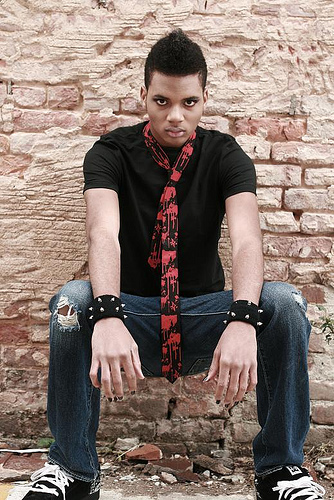Can you describe the setting and how it might relate to the person's mood? The setting appears to be an outdoor scene with a rustic brick wall as the backdrop. The wall's aged and weathered texture, along with the person's serious expression and seated pose, may suggest a contemplative or introspective mood, as if he's ruminating on life or seeking a moment of solitude. Does the environment tell us anything about the time of day or season? While specific details about the time of day or season aren't directly visible, the ambient lighting seems soft and diffused. There are no harsh shadows or bright sunlight, hinting that it could either be a cloudy day or a time closer to dawn or dusk. The person's attire suggests it's not too cold, possibly indicating a season like spring or fall. 